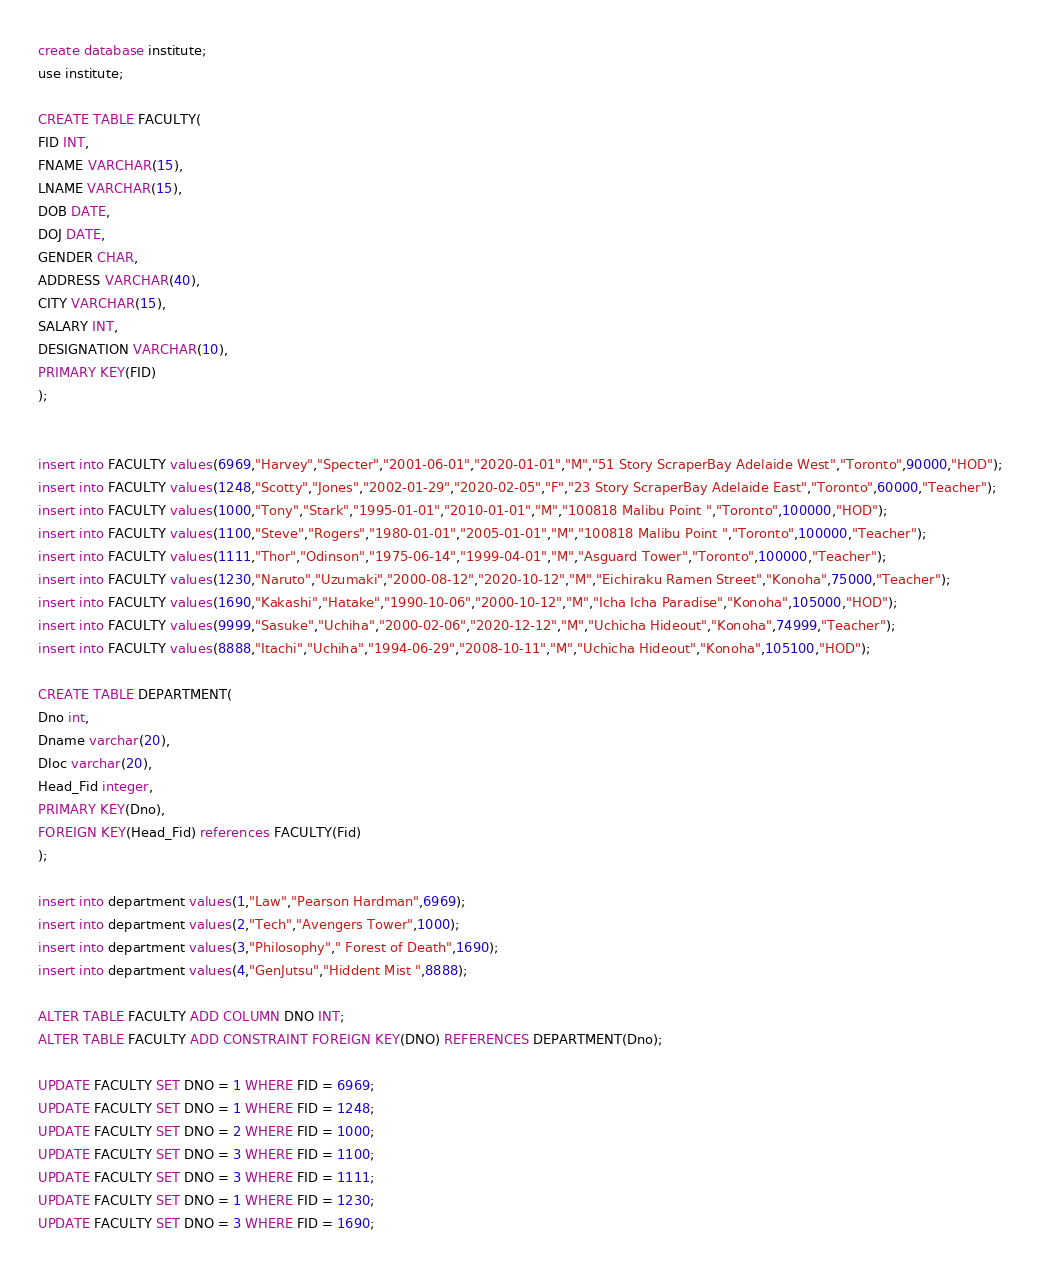<code> <loc_0><loc_0><loc_500><loc_500><_SQL_>create database institute;
use institute;

CREATE TABLE FACULTY(
FID INT,
FNAME VARCHAR(15),
LNAME VARCHAR(15),
DOB DATE,
DOJ DATE,
GENDER CHAR,
ADDRESS VARCHAR(40),
CITY VARCHAR(15),
SALARY INT,
DESIGNATION VARCHAR(10), 
PRIMARY KEY(FID)
);


insert into FACULTY values(6969,"Harvey","Specter","2001-06-01","2020-01-01","M","51 Story ScraperBay Adelaide West","Toronto",90000,"HOD");
insert into FACULTY values(1248,"Scotty","Jones","2002-01-29","2020-02-05","F","23 Story ScraperBay Adelaide East","Toronto",60000,"Teacher");
insert into FACULTY values(1000,"Tony","Stark","1995-01-01","2010-01-01","M","100818 Malibu Point ","Toronto",100000,"HOD");
insert into FACULTY values(1100,"Steve","Rogers","1980-01-01","2005-01-01","M","100818 Malibu Point ","Toronto",100000,"Teacher");
insert into FACULTY values(1111,"Thor","Odinson","1975-06-14","1999-04-01","M","Asguard Tower","Toronto",100000,"Teacher");
insert into FACULTY values(1230,"Naruto","Uzumaki","2000-08-12","2020-10-12","M","Eichiraku Ramen Street","Konoha",75000,"Teacher");
insert into FACULTY values(1690,"Kakashi","Hatake","1990-10-06","2000-10-12","M","Icha Icha Paradise","Konoha",105000,"HOD");
insert into FACULTY values(9999,"Sasuke","Uchiha","2000-02-06","2020-12-12","M","Uchicha Hideout","Konoha",74999,"Teacher");
insert into FACULTY values(8888,"Itachi","Uchiha","1994-06-29","2008-10-11","M","Uchicha Hideout","Konoha",105100,"HOD");

CREATE TABLE DEPARTMENT(
Dno int,
Dname varchar(20),
Dloc varchar(20), 
Head_Fid integer,
PRIMARY KEY(Dno),
FOREIGN KEY(Head_Fid) references FACULTY(Fid)
);

insert into department values(1,"Law","Pearson Hardman",6969);
insert into department values(2,"Tech","Avengers Tower",1000);
insert into department values(3,"Philosophy"," Forest of Death",1690);
insert into department values(4,"GenJutsu","Hiddent Mist ",8888);

ALTER TABLE FACULTY ADD COLUMN DNO INT;
ALTER TABLE FACULTY ADD CONSTRAINT FOREIGN KEY(DNO) REFERENCES DEPARTMENT(Dno);

UPDATE FACULTY SET DNO = 1 WHERE FID = 6969;
UPDATE FACULTY SET DNO = 1 WHERE FID = 1248;
UPDATE FACULTY SET DNO = 2 WHERE FID = 1000;
UPDATE FACULTY SET DNO = 3 WHERE FID = 1100;
UPDATE FACULTY SET DNO = 3 WHERE FID = 1111;
UPDATE FACULTY SET DNO = 1 WHERE FID = 1230;
UPDATE FACULTY SET DNO = 3 WHERE FID = 1690;</code> 